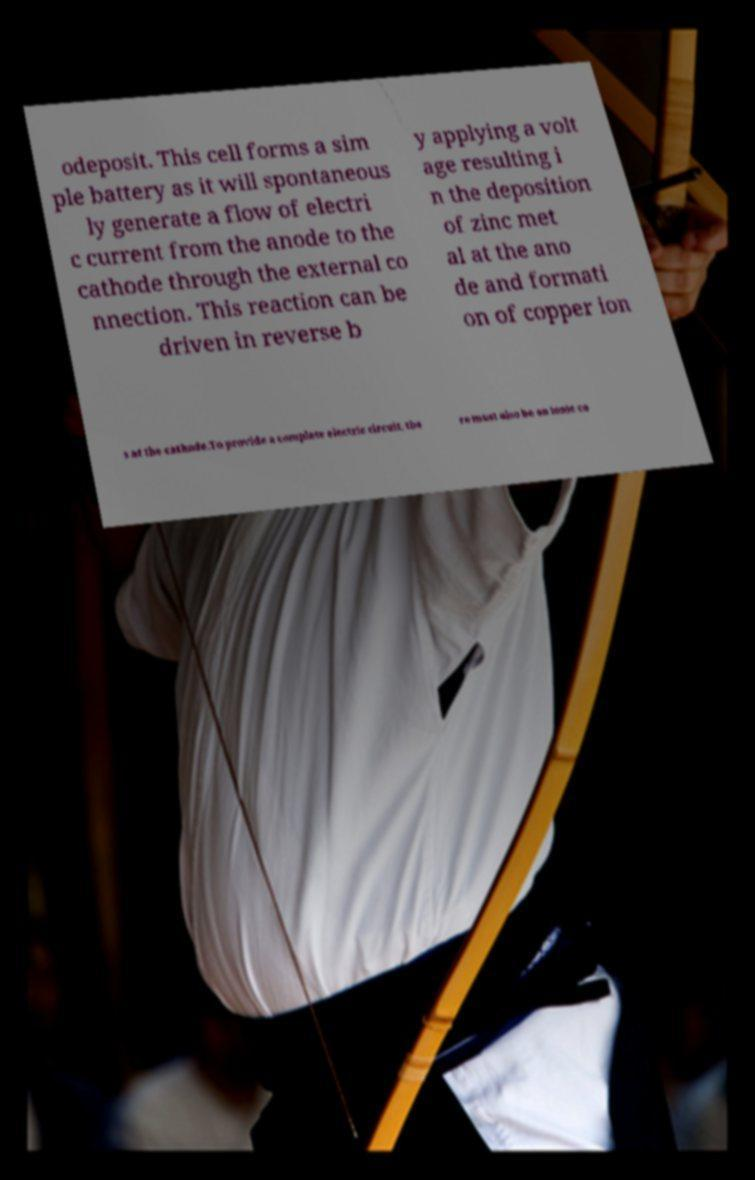Can you read and provide the text displayed in the image?This photo seems to have some interesting text. Can you extract and type it out for me? odeposit. This cell forms a sim ple battery as it will spontaneous ly generate a flow of electri c current from the anode to the cathode through the external co nnection. This reaction can be driven in reverse b y applying a volt age resulting i n the deposition of zinc met al at the ano de and formati on of copper ion s at the cathode.To provide a complete electric circuit, the re must also be an ionic co 